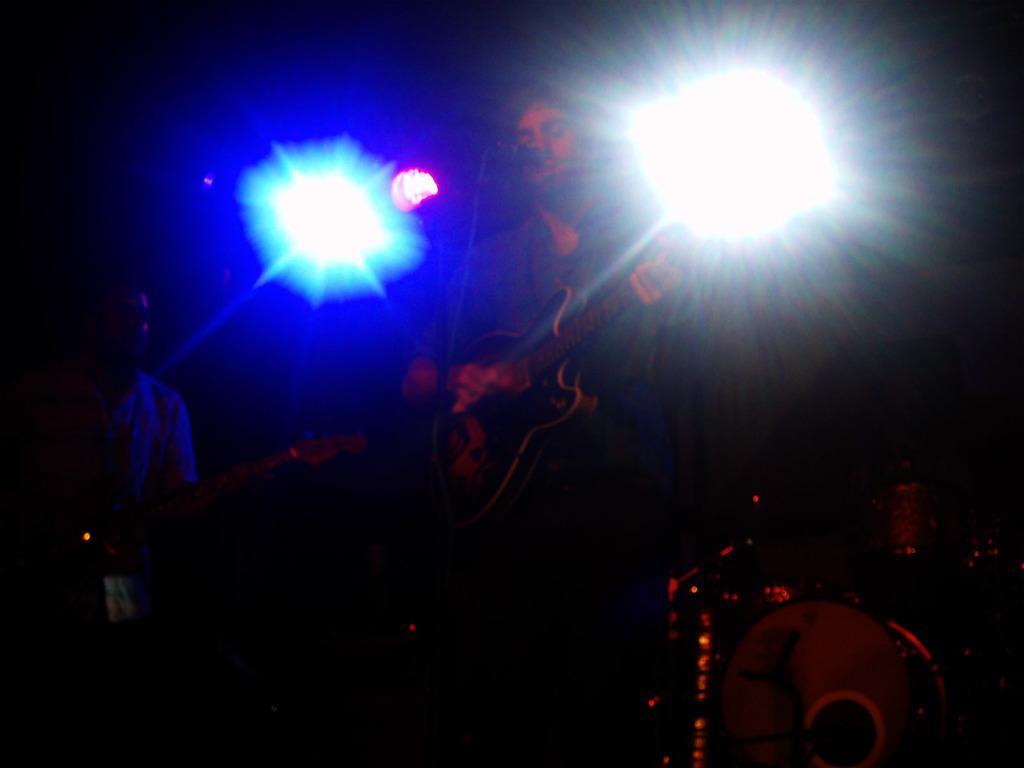In one or two sentences, can you explain what this image depicts? In this picture we can see two men, they are holding guitars, beside them we can see few musical instruments, in the background we can see few lights. 